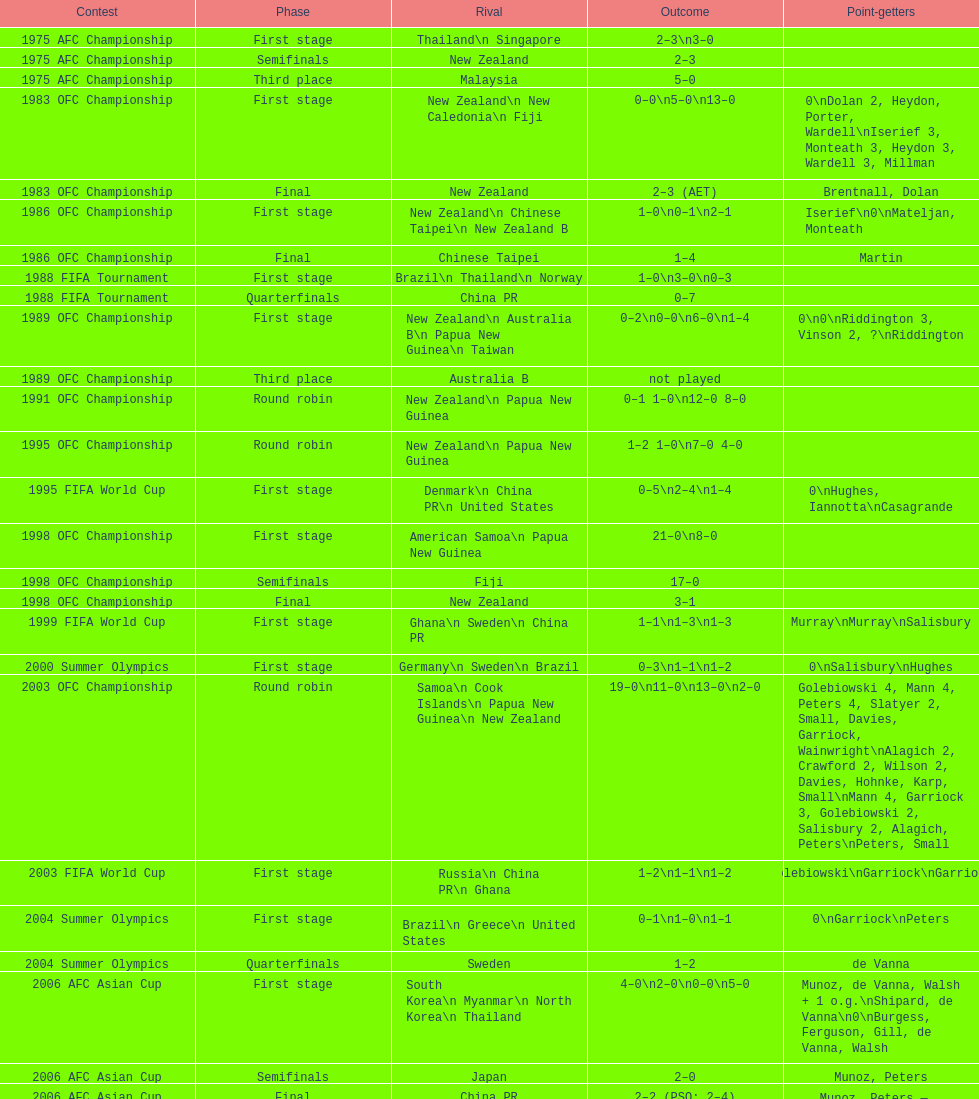Who was this team's next opponent after facing new zealand in the first stage of the 1986 ofc championship? Chinese Taipei. 